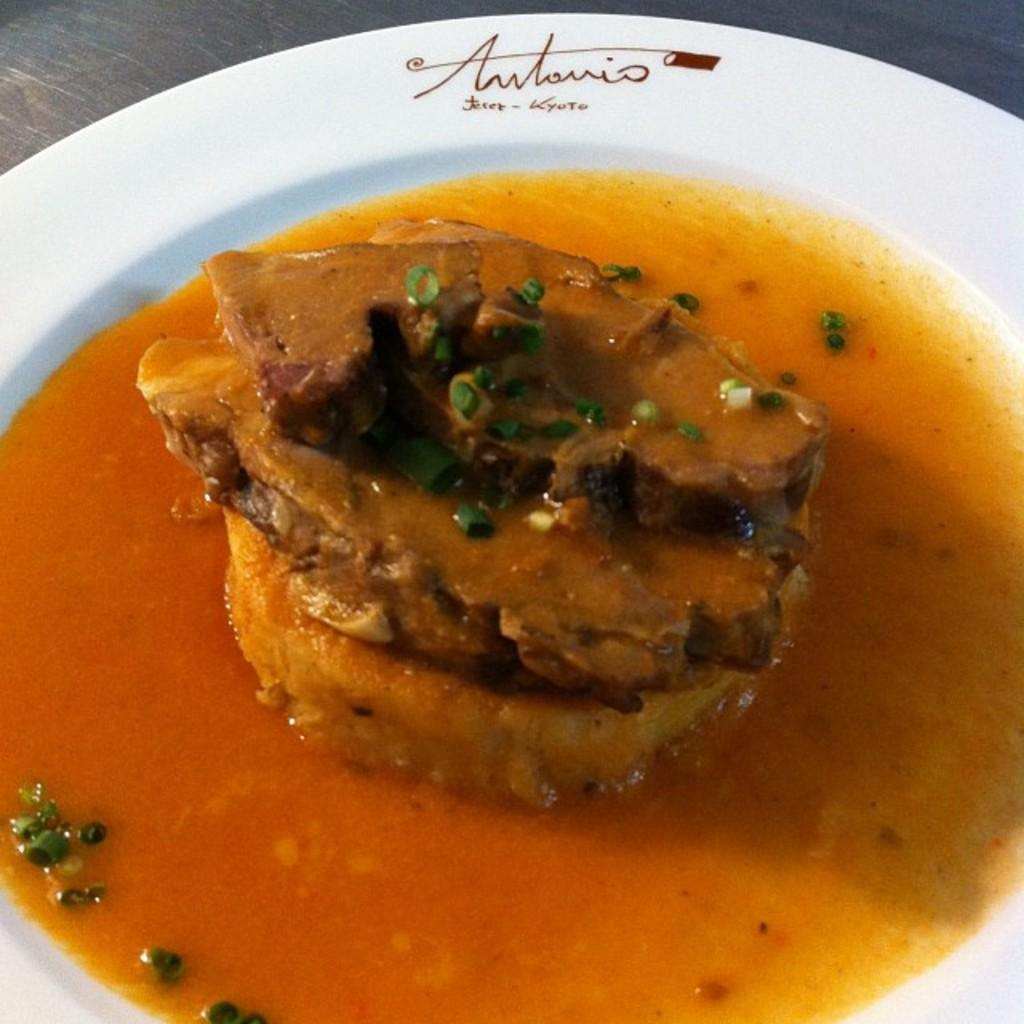What color is the plate that is visible in the image? The plate is white. What is on the plate in the image? The plate contains food items. Where is the plate located in the image? The plate is placed on a table. How much wealth is represented by the food on the plate in the image? The image does not provide any information about the value or wealth represented by the food on the plate. 